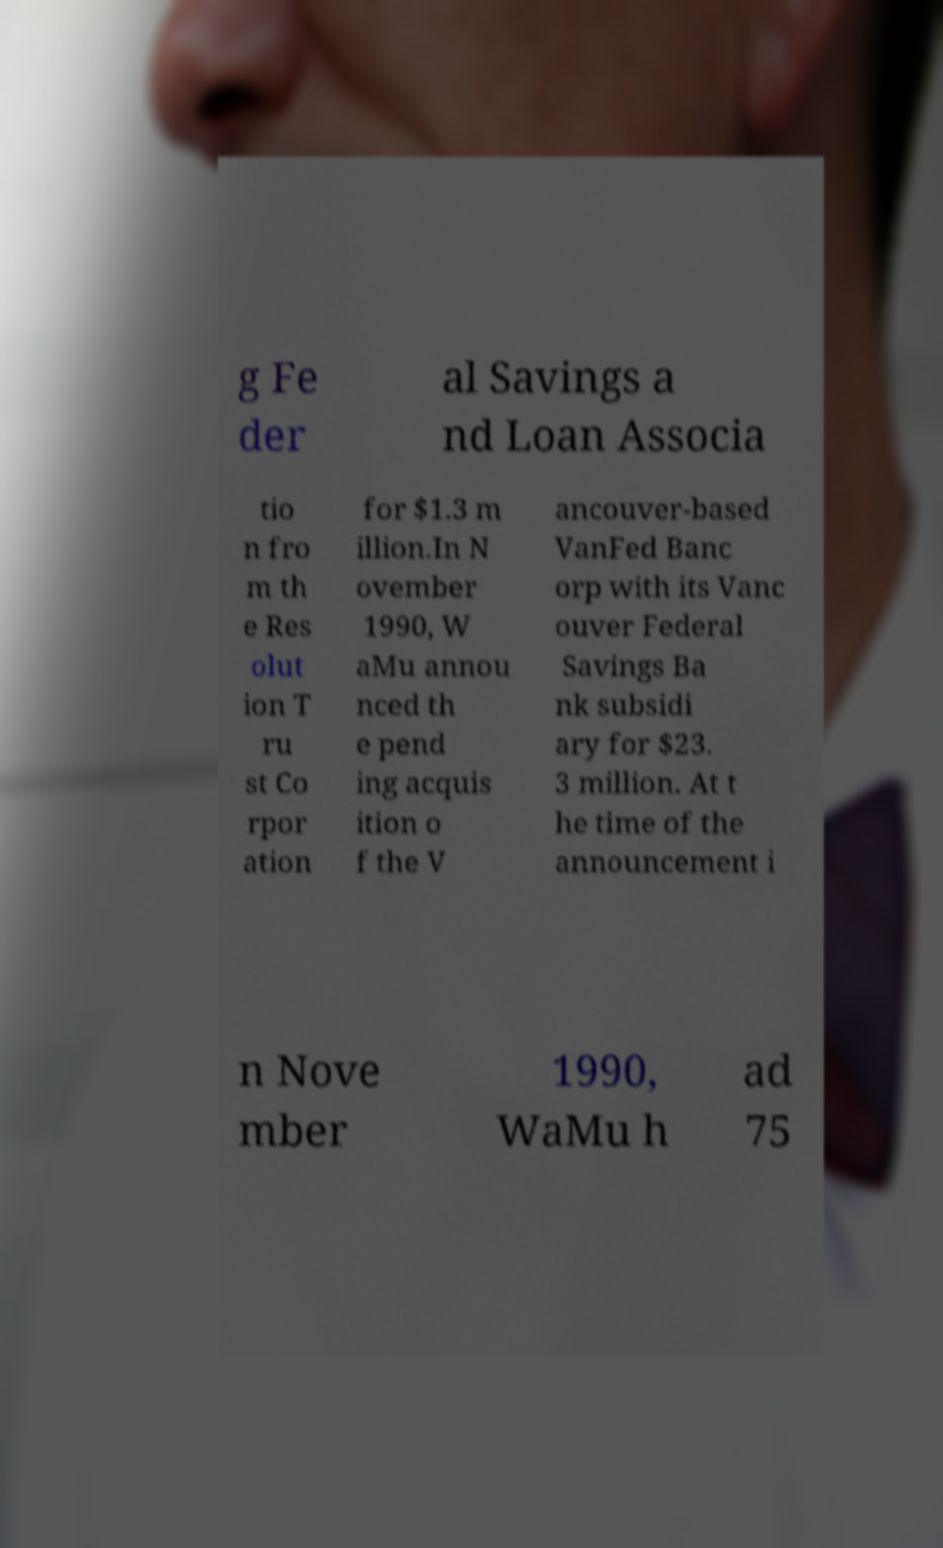Please identify and transcribe the text found in this image. g Fe der al Savings a nd Loan Associa tio n fro m th e Res olut ion T ru st Co rpor ation for $1.3 m illion.In N ovember 1990, W aMu annou nced th e pend ing acquis ition o f the V ancouver-based VanFed Banc orp with its Vanc ouver Federal Savings Ba nk subsidi ary for $23. 3 million. At t he time of the announcement i n Nove mber 1990, WaMu h ad 75 